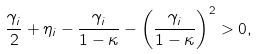<formula> <loc_0><loc_0><loc_500><loc_500>\frac { \gamma _ { i } } { 2 } + \eta _ { i } - \frac { \gamma _ { i } } { 1 - \kappa } - \left ( \frac { \gamma _ { i } } { 1 - \kappa } \right ) ^ { 2 } > 0 ,</formula> 